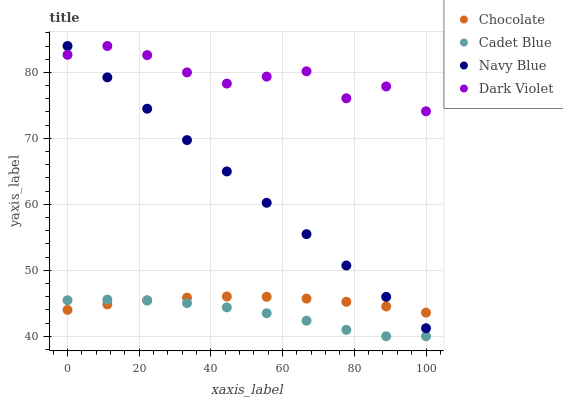Does Cadet Blue have the minimum area under the curve?
Answer yes or no. Yes. Does Dark Violet have the maximum area under the curve?
Answer yes or no. Yes. Does Dark Violet have the minimum area under the curve?
Answer yes or no. No. Does Cadet Blue have the maximum area under the curve?
Answer yes or no. No. Is Navy Blue the smoothest?
Answer yes or no. Yes. Is Dark Violet the roughest?
Answer yes or no. Yes. Is Cadet Blue the smoothest?
Answer yes or no. No. Is Cadet Blue the roughest?
Answer yes or no. No. Does Cadet Blue have the lowest value?
Answer yes or no. Yes. Does Dark Violet have the lowest value?
Answer yes or no. No. Does Dark Violet have the highest value?
Answer yes or no. Yes. Does Cadet Blue have the highest value?
Answer yes or no. No. Is Cadet Blue less than Navy Blue?
Answer yes or no. Yes. Is Navy Blue greater than Cadet Blue?
Answer yes or no. Yes. Does Dark Violet intersect Navy Blue?
Answer yes or no. Yes. Is Dark Violet less than Navy Blue?
Answer yes or no. No. Is Dark Violet greater than Navy Blue?
Answer yes or no. No. Does Cadet Blue intersect Navy Blue?
Answer yes or no. No. 